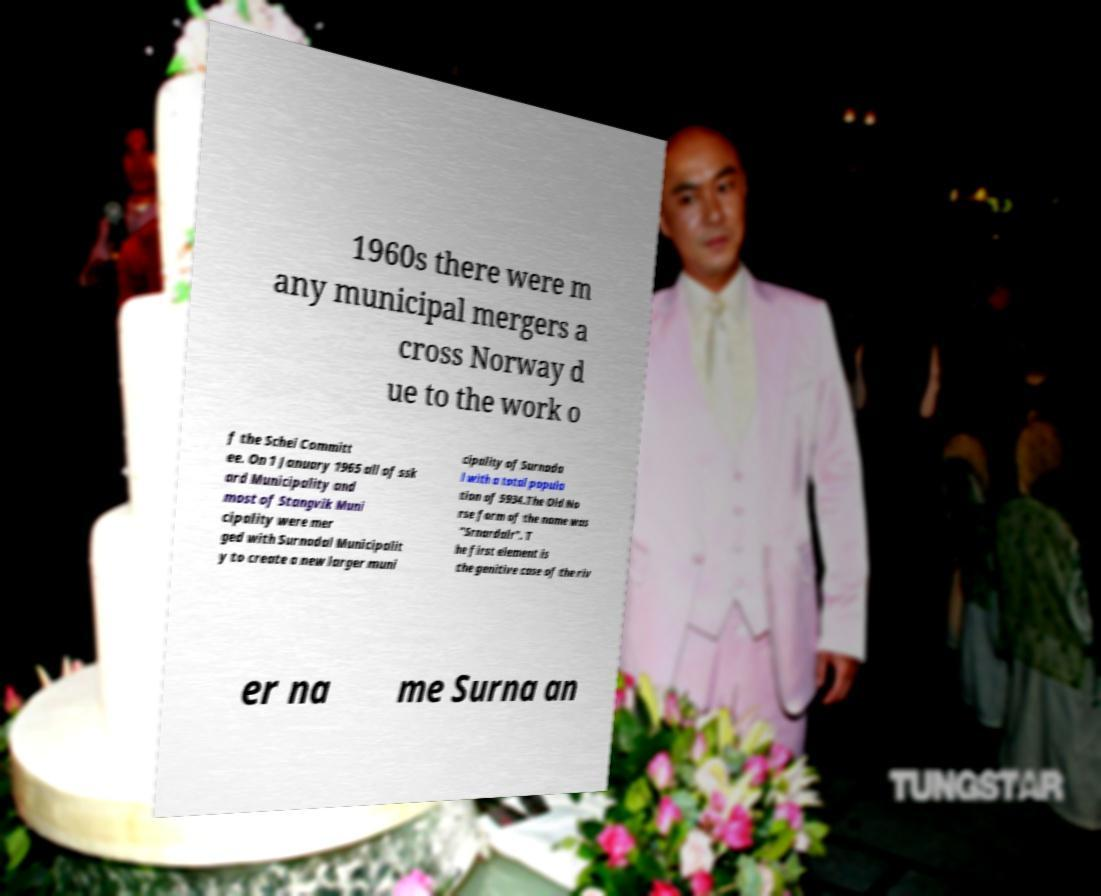Could you assist in decoding the text presented in this image and type it out clearly? 1960s there were m any municipal mergers a cross Norway d ue to the work o f the Schei Committ ee. On 1 January 1965 all of ssk ard Municipality and most of Stangvik Muni cipality were mer ged with Surnadal Municipalit y to create a new larger muni cipality of Surnada l with a total popula tion of 5934.The Old No rse form of the name was "Srnardalr". T he first element is the genitive case of the riv er na me Surna an 